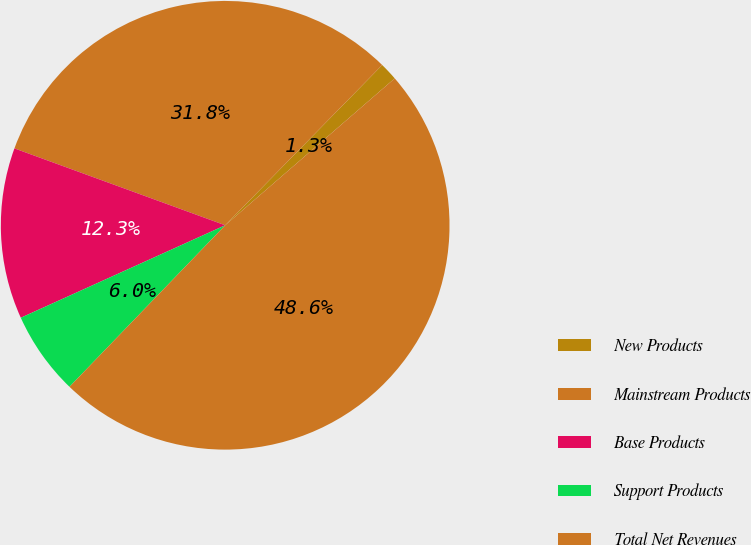<chart> <loc_0><loc_0><loc_500><loc_500><pie_chart><fcel>New Products<fcel>Mainstream Products<fcel>Base Products<fcel>Support Products<fcel>Total Net Revenues<nl><fcel>1.3%<fcel>31.77%<fcel>12.33%<fcel>6.03%<fcel>48.57%<nl></chart> 